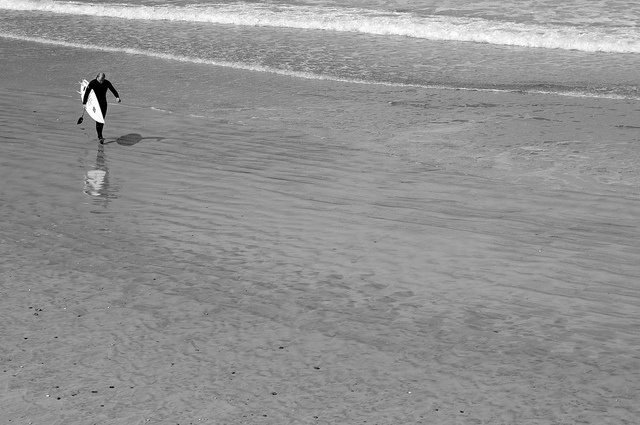Describe the objects in this image and their specific colors. I can see people in lightgray, black, darkgray, and gray tones and surfboard in lightgray, white, darkgray, dimgray, and black tones in this image. 